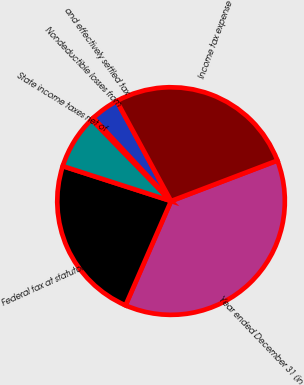Convert chart. <chart><loc_0><loc_0><loc_500><loc_500><pie_chart><fcel>Year ended December 31 (in<fcel>Federal tax at statutory rate<fcel>State income taxes net of<fcel>Nondeductible losses from<fcel>and effectively settled tax<fcel>Income tax expense<nl><fcel>37.35%<fcel>23.42%<fcel>7.74%<fcel>0.34%<fcel>4.04%<fcel>27.12%<nl></chart> 